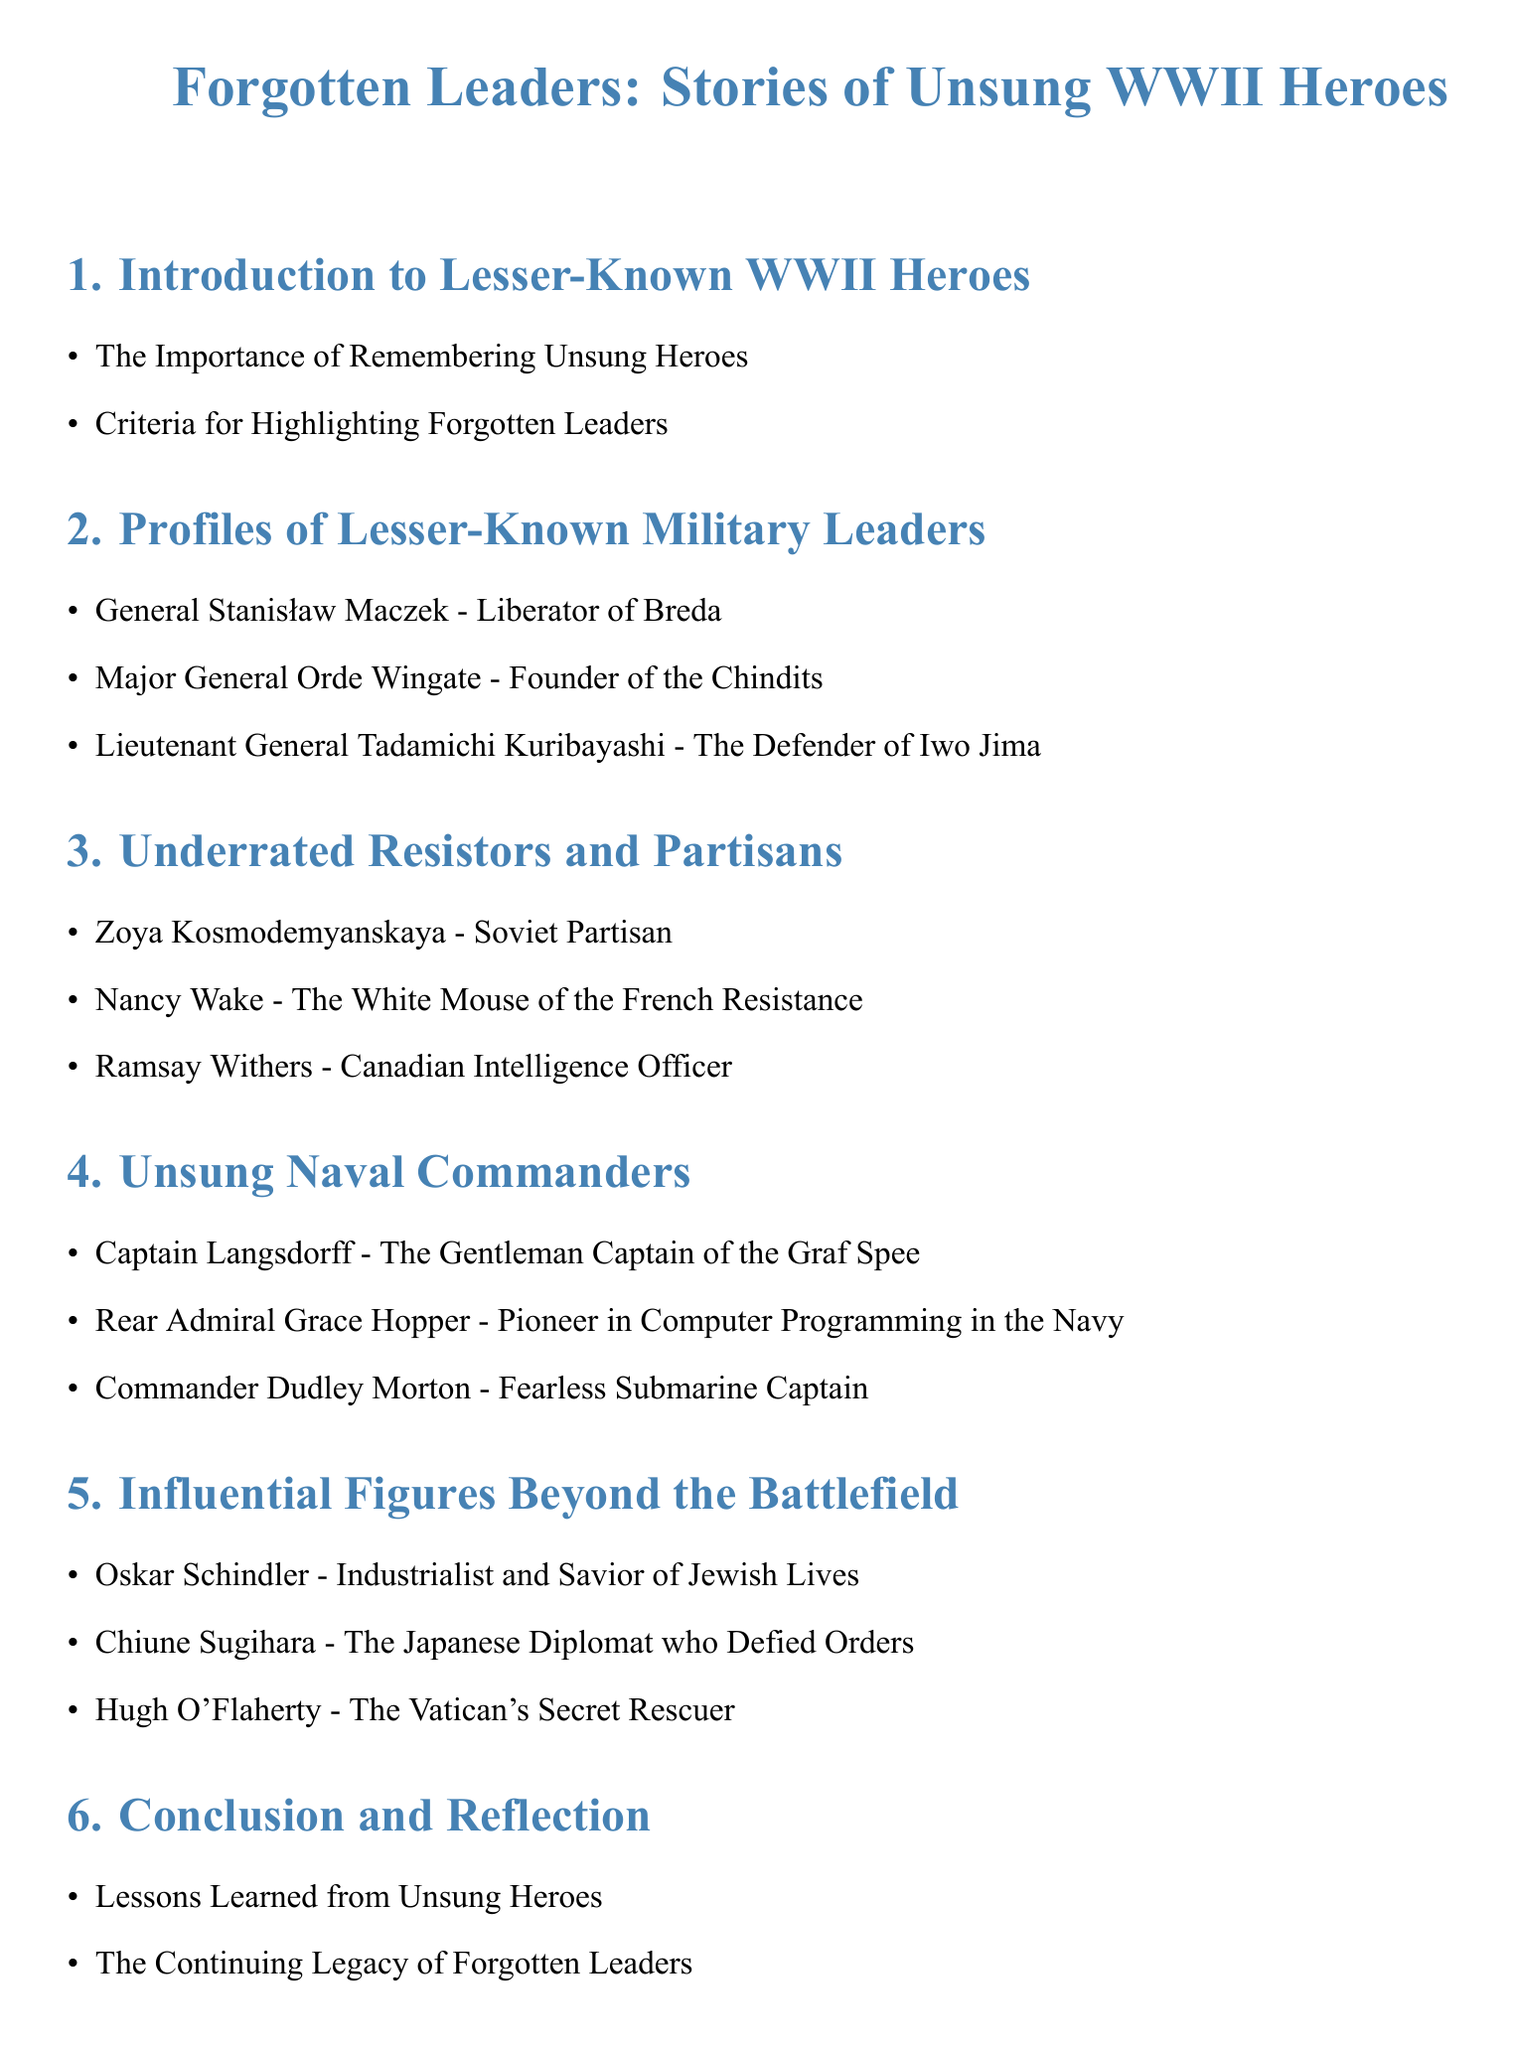What is the title of the document? The title is prominently displayed at the beginning of the document, indicating the focus on lesser-known WWII heroes.
Answer: Forgotten Leaders: Stories of Unsung WWII Heroes What section discusses military leaders? This question identifies the section focused specifically on military leaders in the document.
Answer: Profiles of Lesser-Known Military Leaders Who is known as the "White Mouse"? This identifies the alias of Nancy Wake, who is a notable figure in the French Resistance.
Answer: Nancy Wake Which naval commander is highlighted as a pioneer in computer programming? This question requires recalling the specific naval commander recognized for contributions beyond traditional naval command.
Answer: Rear Admiral Grace Hopper What is the main theme in the conclusion section? This question targets the overarching message conveyed in the conclusion of the document.
Answer: The Continuing Legacy of Forgotten Leaders How many profiles of lesser-known military leaders are presented? This question asks for a quantifiable detail that reflects the content in the section on military leaders.
Answer: Three Who is the defender of Iwo Jima? This focuses on identifying a specific military leader discussed in the profiles section.
Answer: Lieutenant General Tadamichi Kuribayashi What role did Oskar Schindler play during WWII? This question seeks to understand the significance of Oskar Schindler highlighted in the document.
Answer: Savior of Jewish Lives 